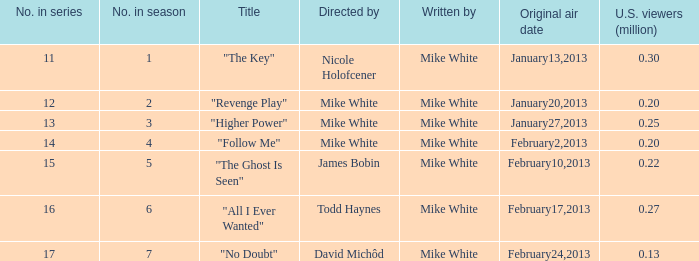Who was the director of the episode that had 250,000 u.s. viewers? Mike White. 